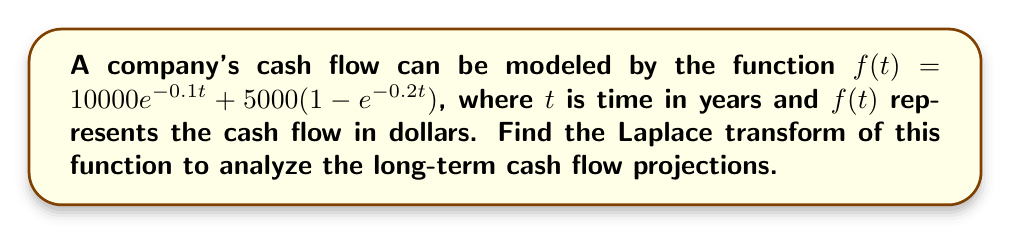Give your solution to this math problem. To solve this problem, we need to apply the Laplace transform to the given function $f(t)$. Let's break it down step by step:

1) The Laplace transform of $f(t)$ is defined as:
   $$\mathcal{L}\{f(t)\} = F(s) = \int_0^\infty e^{-st}f(t)dt$$

2) We need to find $\mathcal{L}\{10000e^{-0.1t} + 5000(1-e^{-0.2t})\}$

3) Using the linearity property of Laplace transforms:
   $$\mathcal{L}\{f(t)\} = 10000\mathcal{L}\{e^{-0.1t}\} + 5000\mathcal{L}\{1\} - 5000\mathcal{L}\{e^{-0.2t}\}$$

4) Now, let's use known Laplace transform pairs:
   - $\mathcal{L}\{e^{at}\} = \frac{1}{s-a}$
   - $\mathcal{L}\{1\} = \frac{1}{s}$

5) Applying these:
   $$F(s) = 10000 \cdot \frac{1}{s+0.1} + 5000 \cdot \frac{1}{s} - 5000 \cdot \frac{1}{s+0.2}$$

6) Finding a common denominator:
   $$F(s) = \frac{10000(s+0.2)}{(s+0.1)(s+0.2)} + \frac{5000(s+0.1)(s+0.2)}{s(s+0.1)(s+0.2)} - \frac{5000(s+0.1)}{(s+0.1)(s+0.2)}$$

7) Simplifying:
   $$F(s) = \frac{10000s + 2000 + 5000s^2 + 1500s - 5000s - 500}{s(s+0.1)(s+0.2)}$$

8) Combining like terms in the numerator:
   $$F(s) = \frac{5000s^2 + 6500s + 1500}{s(s+0.1)(s+0.2)}$$

This is the Laplace transform of the given cash flow function.
Answer: $$F(s) = \frac{5000s^2 + 6500s + 1500}{s(s+0.1)(s+0.2)}$$ 